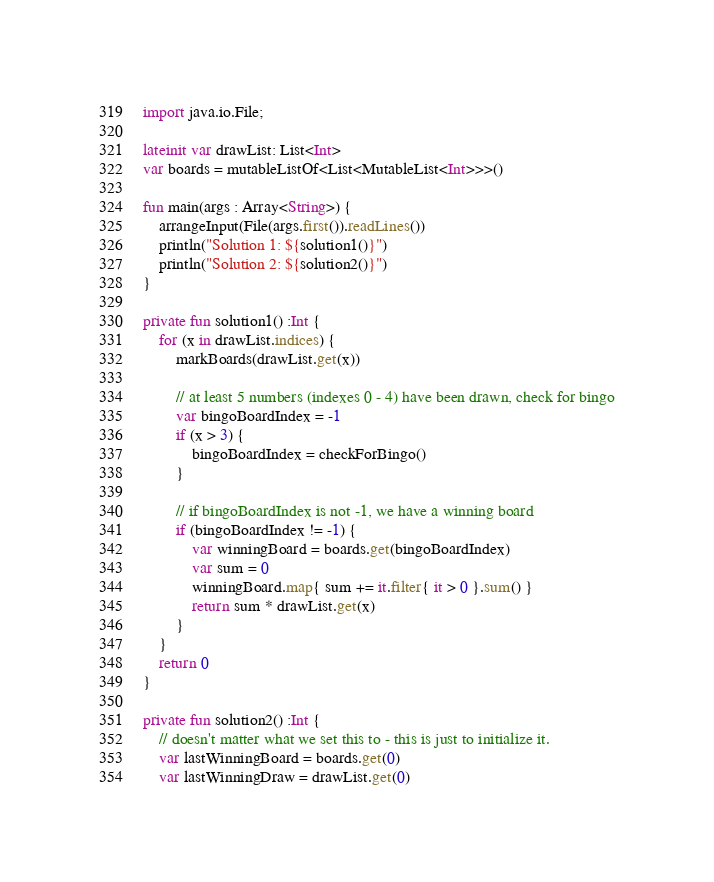Convert code to text. <code><loc_0><loc_0><loc_500><loc_500><_Kotlin_>import java.io.File;

lateinit var drawList: List<Int>
var boards = mutableListOf<List<MutableList<Int>>>()

fun main(args : Array<String>) {
    arrangeInput(File(args.first()).readLines())
    println("Solution 1: ${solution1()}")
    println("Solution 2: ${solution2()}")
}

private fun solution1() :Int {
    for (x in drawList.indices) {
        markBoards(drawList.get(x))

        // at least 5 numbers (indexes 0 - 4) have been drawn, check for bingo
        var bingoBoardIndex = -1
        if (x > 3) {
            bingoBoardIndex = checkForBingo() 
        }

        // if bingoBoardIndex is not -1, we have a winning board
        if (bingoBoardIndex != -1) {
            var winningBoard = boards.get(bingoBoardIndex)
            var sum = 0 
            winningBoard.map{ sum += it.filter{ it > 0 }.sum() }
            return sum * drawList.get(x)
        }
    }
    return 0
}
    
private fun solution2() :Int {
    // doesn't matter what we set this to - this is just to initialize it.
    var lastWinningBoard = boards.get(0)
    var lastWinningDraw = drawList.get(0)
</code> 